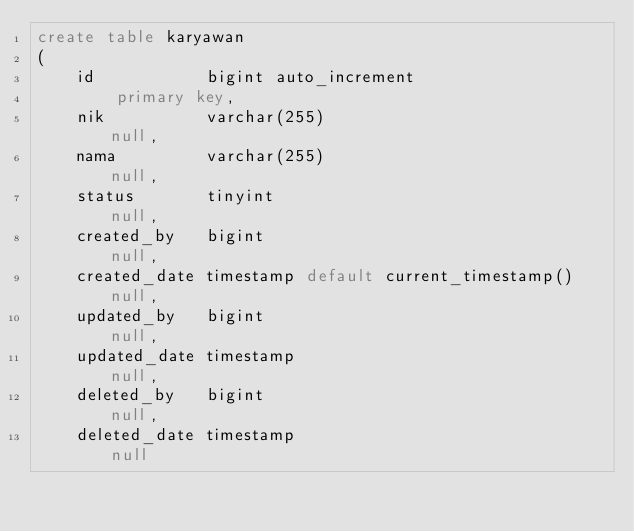Convert code to text. <code><loc_0><loc_0><loc_500><loc_500><_SQL_>create table karyawan
(
    id           bigint auto_increment
        primary key,
    nik          varchar(255)                          null,
    nama         varchar(255)                          null,
    status       tinyint                               null,
    created_by   bigint                                null,
    created_date timestamp default current_timestamp() null,
    updated_by   bigint                                null,
    updated_date timestamp                             null,
    deleted_by   bigint                                null,
    deleted_date timestamp                             null</code> 